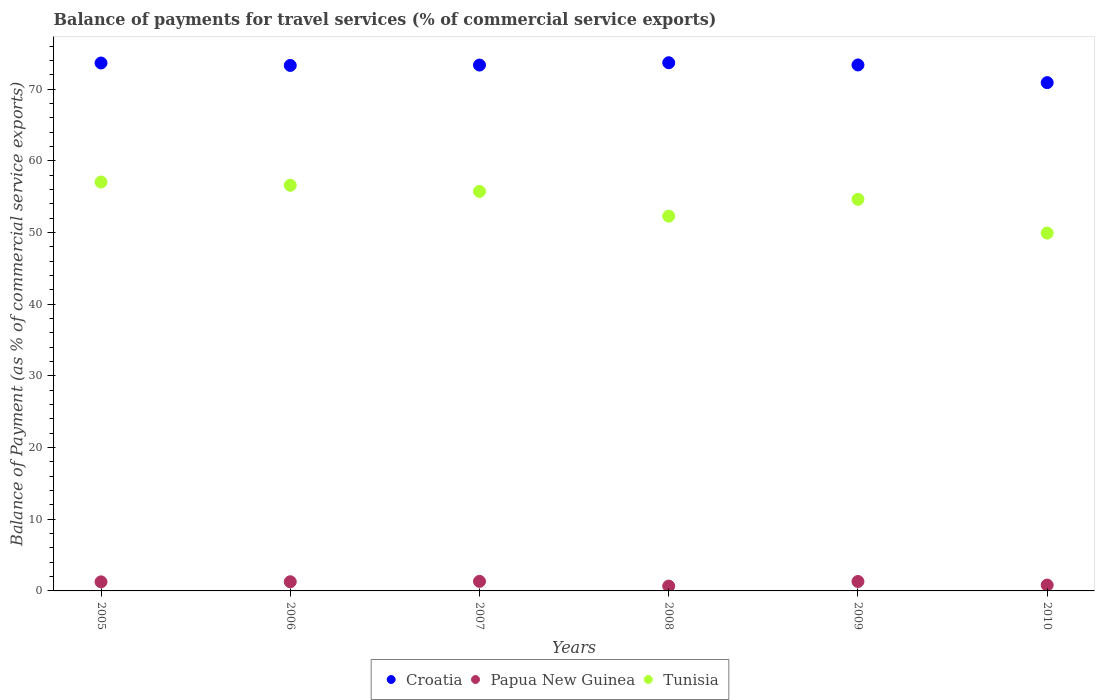What is the balance of payments for travel services in Tunisia in 2006?
Your response must be concise. 56.59. Across all years, what is the maximum balance of payments for travel services in Tunisia?
Your response must be concise. 57.04. Across all years, what is the minimum balance of payments for travel services in Croatia?
Offer a terse response. 70.91. What is the total balance of payments for travel services in Tunisia in the graph?
Offer a terse response. 326.22. What is the difference between the balance of payments for travel services in Papua New Guinea in 2005 and that in 2006?
Your answer should be very brief. -0.01. What is the difference between the balance of payments for travel services in Croatia in 2005 and the balance of payments for travel services in Papua New Guinea in 2008?
Ensure brevity in your answer.  72.97. What is the average balance of payments for travel services in Papua New Guinea per year?
Provide a succinct answer. 1.11. In the year 2008, what is the difference between the balance of payments for travel services in Croatia and balance of payments for travel services in Papua New Guinea?
Ensure brevity in your answer.  73.01. In how many years, is the balance of payments for travel services in Tunisia greater than 34 %?
Your answer should be very brief. 6. What is the ratio of the balance of payments for travel services in Papua New Guinea in 2007 to that in 2010?
Your answer should be very brief. 1.63. Is the difference between the balance of payments for travel services in Croatia in 2008 and 2010 greater than the difference between the balance of payments for travel services in Papua New Guinea in 2008 and 2010?
Give a very brief answer. Yes. What is the difference between the highest and the second highest balance of payments for travel services in Tunisia?
Keep it short and to the point. 0.45. What is the difference between the highest and the lowest balance of payments for travel services in Tunisia?
Give a very brief answer. 7.12. In how many years, is the balance of payments for travel services in Tunisia greater than the average balance of payments for travel services in Tunisia taken over all years?
Make the answer very short. 4. Is the balance of payments for travel services in Papua New Guinea strictly less than the balance of payments for travel services in Tunisia over the years?
Your answer should be very brief. Yes. How many dotlines are there?
Your response must be concise. 3. Does the graph contain grids?
Ensure brevity in your answer.  No. Where does the legend appear in the graph?
Offer a very short reply. Bottom center. How many legend labels are there?
Offer a terse response. 3. What is the title of the graph?
Keep it short and to the point. Balance of payments for travel services (% of commercial service exports). Does "Upper middle income" appear as one of the legend labels in the graph?
Your answer should be compact. No. What is the label or title of the X-axis?
Keep it short and to the point. Years. What is the label or title of the Y-axis?
Your response must be concise. Balance of Payment (as % of commercial service exports). What is the Balance of Payment (as % of commercial service exports) in Croatia in 2005?
Your answer should be compact. 73.65. What is the Balance of Payment (as % of commercial service exports) in Papua New Guinea in 2005?
Your answer should be very brief. 1.27. What is the Balance of Payment (as % of commercial service exports) in Tunisia in 2005?
Your answer should be compact. 57.04. What is the Balance of Payment (as % of commercial service exports) of Croatia in 2006?
Your answer should be compact. 73.31. What is the Balance of Payment (as % of commercial service exports) of Papua New Guinea in 2006?
Your answer should be very brief. 1.28. What is the Balance of Payment (as % of commercial service exports) in Tunisia in 2006?
Offer a very short reply. 56.59. What is the Balance of Payment (as % of commercial service exports) in Croatia in 2007?
Make the answer very short. 73.36. What is the Balance of Payment (as % of commercial service exports) of Papua New Guinea in 2007?
Keep it short and to the point. 1.33. What is the Balance of Payment (as % of commercial service exports) in Tunisia in 2007?
Offer a terse response. 55.74. What is the Balance of Payment (as % of commercial service exports) in Croatia in 2008?
Give a very brief answer. 73.69. What is the Balance of Payment (as % of commercial service exports) of Papua New Guinea in 2008?
Offer a very short reply. 0.68. What is the Balance of Payment (as % of commercial service exports) in Tunisia in 2008?
Provide a succinct answer. 52.29. What is the Balance of Payment (as % of commercial service exports) of Croatia in 2009?
Give a very brief answer. 73.38. What is the Balance of Payment (as % of commercial service exports) of Papua New Guinea in 2009?
Offer a very short reply. 1.31. What is the Balance of Payment (as % of commercial service exports) of Tunisia in 2009?
Provide a succinct answer. 54.63. What is the Balance of Payment (as % of commercial service exports) in Croatia in 2010?
Offer a terse response. 70.91. What is the Balance of Payment (as % of commercial service exports) of Papua New Guinea in 2010?
Ensure brevity in your answer.  0.82. What is the Balance of Payment (as % of commercial service exports) in Tunisia in 2010?
Offer a very short reply. 49.93. Across all years, what is the maximum Balance of Payment (as % of commercial service exports) in Croatia?
Your answer should be compact. 73.69. Across all years, what is the maximum Balance of Payment (as % of commercial service exports) in Papua New Guinea?
Offer a terse response. 1.33. Across all years, what is the maximum Balance of Payment (as % of commercial service exports) of Tunisia?
Provide a short and direct response. 57.04. Across all years, what is the minimum Balance of Payment (as % of commercial service exports) of Croatia?
Ensure brevity in your answer.  70.91. Across all years, what is the minimum Balance of Payment (as % of commercial service exports) in Papua New Guinea?
Ensure brevity in your answer.  0.68. Across all years, what is the minimum Balance of Payment (as % of commercial service exports) in Tunisia?
Ensure brevity in your answer.  49.93. What is the total Balance of Payment (as % of commercial service exports) of Croatia in the graph?
Provide a short and direct response. 438.3. What is the total Balance of Payment (as % of commercial service exports) of Papua New Guinea in the graph?
Offer a very short reply. 6.69. What is the total Balance of Payment (as % of commercial service exports) of Tunisia in the graph?
Ensure brevity in your answer.  326.22. What is the difference between the Balance of Payment (as % of commercial service exports) of Croatia in 2005 and that in 2006?
Your response must be concise. 0.34. What is the difference between the Balance of Payment (as % of commercial service exports) in Papua New Guinea in 2005 and that in 2006?
Offer a very short reply. -0.01. What is the difference between the Balance of Payment (as % of commercial service exports) of Tunisia in 2005 and that in 2006?
Your response must be concise. 0.45. What is the difference between the Balance of Payment (as % of commercial service exports) of Croatia in 2005 and that in 2007?
Ensure brevity in your answer.  0.29. What is the difference between the Balance of Payment (as % of commercial service exports) in Papua New Guinea in 2005 and that in 2007?
Provide a succinct answer. -0.07. What is the difference between the Balance of Payment (as % of commercial service exports) of Tunisia in 2005 and that in 2007?
Ensure brevity in your answer.  1.3. What is the difference between the Balance of Payment (as % of commercial service exports) in Croatia in 2005 and that in 2008?
Ensure brevity in your answer.  -0.04. What is the difference between the Balance of Payment (as % of commercial service exports) in Papua New Guinea in 2005 and that in 2008?
Your response must be concise. 0.59. What is the difference between the Balance of Payment (as % of commercial service exports) in Tunisia in 2005 and that in 2008?
Make the answer very short. 4.76. What is the difference between the Balance of Payment (as % of commercial service exports) in Croatia in 2005 and that in 2009?
Offer a terse response. 0.27. What is the difference between the Balance of Payment (as % of commercial service exports) of Papua New Guinea in 2005 and that in 2009?
Offer a very short reply. -0.05. What is the difference between the Balance of Payment (as % of commercial service exports) in Tunisia in 2005 and that in 2009?
Ensure brevity in your answer.  2.41. What is the difference between the Balance of Payment (as % of commercial service exports) of Croatia in 2005 and that in 2010?
Your answer should be very brief. 2.74. What is the difference between the Balance of Payment (as % of commercial service exports) of Papua New Guinea in 2005 and that in 2010?
Your answer should be compact. 0.45. What is the difference between the Balance of Payment (as % of commercial service exports) of Tunisia in 2005 and that in 2010?
Your response must be concise. 7.12. What is the difference between the Balance of Payment (as % of commercial service exports) in Croatia in 2006 and that in 2007?
Provide a short and direct response. -0.05. What is the difference between the Balance of Payment (as % of commercial service exports) of Papua New Guinea in 2006 and that in 2007?
Make the answer very short. -0.06. What is the difference between the Balance of Payment (as % of commercial service exports) of Tunisia in 2006 and that in 2007?
Your response must be concise. 0.85. What is the difference between the Balance of Payment (as % of commercial service exports) in Croatia in 2006 and that in 2008?
Ensure brevity in your answer.  -0.38. What is the difference between the Balance of Payment (as % of commercial service exports) in Papua New Guinea in 2006 and that in 2008?
Offer a terse response. 0.6. What is the difference between the Balance of Payment (as % of commercial service exports) in Tunisia in 2006 and that in 2008?
Your response must be concise. 4.31. What is the difference between the Balance of Payment (as % of commercial service exports) in Croatia in 2006 and that in 2009?
Make the answer very short. -0.07. What is the difference between the Balance of Payment (as % of commercial service exports) of Papua New Guinea in 2006 and that in 2009?
Ensure brevity in your answer.  -0.04. What is the difference between the Balance of Payment (as % of commercial service exports) in Tunisia in 2006 and that in 2009?
Provide a short and direct response. 1.96. What is the difference between the Balance of Payment (as % of commercial service exports) of Croatia in 2006 and that in 2010?
Provide a short and direct response. 2.4. What is the difference between the Balance of Payment (as % of commercial service exports) in Papua New Guinea in 2006 and that in 2010?
Provide a short and direct response. 0.46. What is the difference between the Balance of Payment (as % of commercial service exports) in Tunisia in 2006 and that in 2010?
Give a very brief answer. 6.67. What is the difference between the Balance of Payment (as % of commercial service exports) of Croatia in 2007 and that in 2008?
Provide a short and direct response. -0.32. What is the difference between the Balance of Payment (as % of commercial service exports) of Papua New Guinea in 2007 and that in 2008?
Offer a terse response. 0.66. What is the difference between the Balance of Payment (as % of commercial service exports) of Tunisia in 2007 and that in 2008?
Ensure brevity in your answer.  3.45. What is the difference between the Balance of Payment (as % of commercial service exports) in Croatia in 2007 and that in 2009?
Offer a very short reply. -0.02. What is the difference between the Balance of Payment (as % of commercial service exports) in Papua New Guinea in 2007 and that in 2009?
Provide a short and direct response. 0.02. What is the difference between the Balance of Payment (as % of commercial service exports) in Tunisia in 2007 and that in 2009?
Your response must be concise. 1.1. What is the difference between the Balance of Payment (as % of commercial service exports) in Croatia in 2007 and that in 2010?
Provide a succinct answer. 2.45. What is the difference between the Balance of Payment (as % of commercial service exports) in Papua New Guinea in 2007 and that in 2010?
Make the answer very short. 0.52. What is the difference between the Balance of Payment (as % of commercial service exports) of Tunisia in 2007 and that in 2010?
Keep it short and to the point. 5.81. What is the difference between the Balance of Payment (as % of commercial service exports) of Croatia in 2008 and that in 2009?
Keep it short and to the point. 0.31. What is the difference between the Balance of Payment (as % of commercial service exports) of Papua New Guinea in 2008 and that in 2009?
Your response must be concise. -0.64. What is the difference between the Balance of Payment (as % of commercial service exports) of Tunisia in 2008 and that in 2009?
Ensure brevity in your answer.  -2.35. What is the difference between the Balance of Payment (as % of commercial service exports) in Croatia in 2008 and that in 2010?
Provide a succinct answer. 2.78. What is the difference between the Balance of Payment (as % of commercial service exports) in Papua New Guinea in 2008 and that in 2010?
Your answer should be very brief. -0.14. What is the difference between the Balance of Payment (as % of commercial service exports) in Tunisia in 2008 and that in 2010?
Your answer should be very brief. 2.36. What is the difference between the Balance of Payment (as % of commercial service exports) of Croatia in 2009 and that in 2010?
Your answer should be very brief. 2.47. What is the difference between the Balance of Payment (as % of commercial service exports) in Papua New Guinea in 2009 and that in 2010?
Your response must be concise. 0.5. What is the difference between the Balance of Payment (as % of commercial service exports) of Tunisia in 2009 and that in 2010?
Provide a succinct answer. 4.71. What is the difference between the Balance of Payment (as % of commercial service exports) of Croatia in 2005 and the Balance of Payment (as % of commercial service exports) of Papua New Guinea in 2006?
Provide a short and direct response. 72.37. What is the difference between the Balance of Payment (as % of commercial service exports) in Croatia in 2005 and the Balance of Payment (as % of commercial service exports) in Tunisia in 2006?
Your answer should be compact. 17.06. What is the difference between the Balance of Payment (as % of commercial service exports) of Papua New Guinea in 2005 and the Balance of Payment (as % of commercial service exports) of Tunisia in 2006?
Provide a short and direct response. -55.33. What is the difference between the Balance of Payment (as % of commercial service exports) of Croatia in 2005 and the Balance of Payment (as % of commercial service exports) of Papua New Guinea in 2007?
Your response must be concise. 72.32. What is the difference between the Balance of Payment (as % of commercial service exports) of Croatia in 2005 and the Balance of Payment (as % of commercial service exports) of Tunisia in 2007?
Provide a succinct answer. 17.91. What is the difference between the Balance of Payment (as % of commercial service exports) of Papua New Guinea in 2005 and the Balance of Payment (as % of commercial service exports) of Tunisia in 2007?
Offer a very short reply. -54.47. What is the difference between the Balance of Payment (as % of commercial service exports) of Croatia in 2005 and the Balance of Payment (as % of commercial service exports) of Papua New Guinea in 2008?
Your answer should be very brief. 72.97. What is the difference between the Balance of Payment (as % of commercial service exports) in Croatia in 2005 and the Balance of Payment (as % of commercial service exports) in Tunisia in 2008?
Offer a very short reply. 21.36. What is the difference between the Balance of Payment (as % of commercial service exports) of Papua New Guinea in 2005 and the Balance of Payment (as % of commercial service exports) of Tunisia in 2008?
Provide a succinct answer. -51.02. What is the difference between the Balance of Payment (as % of commercial service exports) of Croatia in 2005 and the Balance of Payment (as % of commercial service exports) of Papua New Guinea in 2009?
Provide a short and direct response. 72.34. What is the difference between the Balance of Payment (as % of commercial service exports) of Croatia in 2005 and the Balance of Payment (as % of commercial service exports) of Tunisia in 2009?
Your answer should be very brief. 19.02. What is the difference between the Balance of Payment (as % of commercial service exports) in Papua New Guinea in 2005 and the Balance of Payment (as % of commercial service exports) in Tunisia in 2009?
Ensure brevity in your answer.  -53.37. What is the difference between the Balance of Payment (as % of commercial service exports) in Croatia in 2005 and the Balance of Payment (as % of commercial service exports) in Papua New Guinea in 2010?
Offer a terse response. 72.83. What is the difference between the Balance of Payment (as % of commercial service exports) in Croatia in 2005 and the Balance of Payment (as % of commercial service exports) in Tunisia in 2010?
Keep it short and to the point. 23.72. What is the difference between the Balance of Payment (as % of commercial service exports) of Papua New Guinea in 2005 and the Balance of Payment (as % of commercial service exports) of Tunisia in 2010?
Keep it short and to the point. -48.66. What is the difference between the Balance of Payment (as % of commercial service exports) of Croatia in 2006 and the Balance of Payment (as % of commercial service exports) of Papua New Guinea in 2007?
Keep it short and to the point. 71.97. What is the difference between the Balance of Payment (as % of commercial service exports) of Croatia in 2006 and the Balance of Payment (as % of commercial service exports) of Tunisia in 2007?
Offer a terse response. 17.57. What is the difference between the Balance of Payment (as % of commercial service exports) in Papua New Guinea in 2006 and the Balance of Payment (as % of commercial service exports) in Tunisia in 2007?
Offer a very short reply. -54.46. What is the difference between the Balance of Payment (as % of commercial service exports) in Croatia in 2006 and the Balance of Payment (as % of commercial service exports) in Papua New Guinea in 2008?
Provide a short and direct response. 72.63. What is the difference between the Balance of Payment (as % of commercial service exports) in Croatia in 2006 and the Balance of Payment (as % of commercial service exports) in Tunisia in 2008?
Your answer should be compact. 21.02. What is the difference between the Balance of Payment (as % of commercial service exports) in Papua New Guinea in 2006 and the Balance of Payment (as % of commercial service exports) in Tunisia in 2008?
Ensure brevity in your answer.  -51.01. What is the difference between the Balance of Payment (as % of commercial service exports) in Croatia in 2006 and the Balance of Payment (as % of commercial service exports) in Papua New Guinea in 2009?
Your answer should be compact. 71.99. What is the difference between the Balance of Payment (as % of commercial service exports) of Croatia in 2006 and the Balance of Payment (as % of commercial service exports) of Tunisia in 2009?
Offer a very short reply. 18.67. What is the difference between the Balance of Payment (as % of commercial service exports) in Papua New Guinea in 2006 and the Balance of Payment (as % of commercial service exports) in Tunisia in 2009?
Your response must be concise. -53.36. What is the difference between the Balance of Payment (as % of commercial service exports) of Croatia in 2006 and the Balance of Payment (as % of commercial service exports) of Papua New Guinea in 2010?
Your answer should be compact. 72.49. What is the difference between the Balance of Payment (as % of commercial service exports) in Croatia in 2006 and the Balance of Payment (as % of commercial service exports) in Tunisia in 2010?
Ensure brevity in your answer.  23.38. What is the difference between the Balance of Payment (as % of commercial service exports) in Papua New Guinea in 2006 and the Balance of Payment (as % of commercial service exports) in Tunisia in 2010?
Your answer should be compact. -48.65. What is the difference between the Balance of Payment (as % of commercial service exports) of Croatia in 2007 and the Balance of Payment (as % of commercial service exports) of Papua New Guinea in 2008?
Offer a very short reply. 72.69. What is the difference between the Balance of Payment (as % of commercial service exports) of Croatia in 2007 and the Balance of Payment (as % of commercial service exports) of Tunisia in 2008?
Provide a short and direct response. 21.08. What is the difference between the Balance of Payment (as % of commercial service exports) in Papua New Guinea in 2007 and the Balance of Payment (as % of commercial service exports) in Tunisia in 2008?
Your answer should be very brief. -50.95. What is the difference between the Balance of Payment (as % of commercial service exports) in Croatia in 2007 and the Balance of Payment (as % of commercial service exports) in Papua New Guinea in 2009?
Keep it short and to the point. 72.05. What is the difference between the Balance of Payment (as % of commercial service exports) of Croatia in 2007 and the Balance of Payment (as % of commercial service exports) of Tunisia in 2009?
Offer a terse response. 18.73. What is the difference between the Balance of Payment (as % of commercial service exports) in Papua New Guinea in 2007 and the Balance of Payment (as % of commercial service exports) in Tunisia in 2009?
Provide a succinct answer. -53.3. What is the difference between the Balance of Payment (as % of commercial service exports) in Croatia in 2007 and the Balance of Payment (as % of commercial service exports) in Papua New Guinea in 2010?
Keep it short and to the point. 72.55. What is the difference between the Balance of Payment (as % of commercial service exports) in Croatia in 2007 and the Balance of Payment (as % of commercial service exports) in Tunisia in 2010?
Your answer should be very brief. 23.44. What is the difference between the Balance of Payment (as % of commercial service exports) in Papua New Guinea in 2007 and the Balance of Payment (as % of commercial service exports) in Tunisia in 2010?
Provide a succinct answer. -48.59. What is the difference between the Balance of Payment (as % of commercial service exports) of Croatia in 2008 and the Balance of Payment (as % of commercial service exports) of Papua New Guinea in 2009?
Provide a short and direct response. 72.37. What is the difference between the Balance of Payment (as % of commercial service exports) in Croatia in 2008 and the Balance of Payment (as % of commercial service exports) in Tunisia in 2009?
Make the answer very short. 19.05. What is the difference between the Balance of Payment (as % of commercial service exports) of Papua New Guinea in 2008 and the Balance of Payment (as % of commercial service exports) of Tunisia in 2009?
Your answer should be very brief. -53.96. What is the difference between the Balance of Payment (as % of commercial service exports) in Croatia in 2008 and the Balance of Payment (as % of commercial service exports) in Papua New Guinea in 2010?
Provide a succinct answer. 72.87. What is the difference between the Balance of Payment (as % of commercial service exports) of Croatia in 2008 and the Balance of Payment (as % of commercial service exports) of Tunisia in 2010?
Your answer should be very brief. 23.76. What is the difference between the Balance of Payment (as % of commercial service exports) in Papua New Guinea in 2008 and the Balance of Payment (as % of commercial service exports) in Tunisia in 2010?
Give a very brief answer. -49.25. What is the difference between the Balance of Payment (as % of commercial service exports) of Croatia in 2009 and the Balance of Payment (as % of commercial service exports) of Papua New Guinea in 2010?
Give a very brief answer. 72.56. What is the difference between the Balance of Payment (as % of commercial service exports) in Croatia in 2009 and the Balance of Payment (as % of commercial service exports) in Tunisia in 2010?
Your response must be concise. 23.45. What is the difference between the Balance of Payment (as % of commercial service exports) of Papua New Guinea in 2009 and the Balance of Payment (as % of commercial service exports) of Tunisia in 2010?
Make the answer very short. -48.61. What is the average Balance of Payment (as % of commercial service exports) of Croatia per year?
Offer a very short reply. 73.05. What is the average Balance of Payment (as % of commercial service exports) in Papua New Guinea per year?
Your response must be concise. 1.11. What is the average Balance of Payment (as % of commercial service exports) of Tunisia per year?
Your response must be concise. 54.37. In the year 2005, what is the difference between the Balance of Payment (as % of commercial service exports) in Croatia and Balance of Payment (as % of commercial service exports) in Papua New Guinea?
Your response must be concise. 72.39. In the year 2005, what is the difference between the Balance of Payment (as % of commercial service exports) of Croatia and Balance of Payment (as % of commercial service exports) of Tunisia?
Give a very brief answer. 16.61. In the year 2005, what is the difference between the Balance of Payment (as % of commercial service exports) in Papua New Guinea and Balance of Payment (as % of commercial service exports) in Tunisia?
Give a very brief answer. -55.78. In the year 2006, what is the difference between the Balance of Payment (as % of commercial service exports) in Croatia and Balance of Payment (as % of commercial service exports) in Papua New Guinea?
Your answer should be compact. 72.03. In the year 2006, what is the difference between the Balance of Payment (as % of commercial service exports) of Croatia and Balance of Payment (as % of commercial service exports) of Tunisia?
Provide a short and direct response. 16.72. In the year 2006, what is the difference between the Balance of Payment (as % of commercial service exports) of Papua New Guinea and Balance of Payment (as % of commercial service exports) of Tunisia?
Keep it short and to the point. -55.31. In the year 2007, what is the difference between the Balance of Payment (as % of commercial service exports) of Croatia and Balance of Payment (as % of commercial service exports) of Papua New Guinea?
Ensure brevity in your answer.  72.03. In the year 2007, what is the difference between the Balance of Payment (as % of commercial service exports) of Croatia and Balance of Payment (as % of commercial service exports) of Tunisia?
Provide a short and direct response. 17.62. In the year 2007, what is the difference between the Balance of Payment (as % of commercial service exports) in Papua New Guinea and Balance of Payment (as % of commercial service exports) in Tunisia?
Your answer should be very brief. -54.4. In the year 2008, what is the difference between the Balance of Payment (as % of commercial service exports) of Croatia and Balance of Payment (as % of commercial service exports) of Papua New Guinea?
Keep it short and to the point. 73.01. In the year 2008, what is the difference between the Balance of Payment (as % of commercial service exports) in Croatia and Balance of Payment (as % of commercial service exports) in Tunisia?
Offer a terse response. 21.4. In the year 2008, what is the difference between the Balance of Payment (as % of commercial service exports) in Papua New Guinea and Balance of Payment (as % of commercial service exports) in Tunisia?
Provide a short and direct response. -51.61. In the year 2009, what is the difference between the Balance of Payment (as % of commercial service exports) of Croatia and Balance of Payment (as % of commercial service exports) of Papua New Guinea?
Your answer should be compact. 72.06. In the year 2009, what is the difference between the Balance of Payment (as % of commercial service exports) of Croatia and Balance of Payment (as % of commercial service exports) of Tunisia?
Give a very brief answer. 18.74. In the year 2009, what is the difference between the Balance of Payment (as % of commercial service exports) in Papua New Guinea and Balance of Payment (as % of commercial service exports) in Tunisia?
Provide a succinct answer. -53.32. In the year 2010, what is the difference between the Balance of Payment (as % of commercial service exports) in Croatia and Balance of Payment (as % of commercial service exports) in Papua New Guinea?
Offer a terse response. 70.09. In the year 2010, what is the difference between the Balance of Payment (as % of commercial service exports) in Croatia and Balance of Payment (as % of commercial service exports) in Tunisia?
Provide a short and direct response. 20.98. In the year 2010, what is the difference between the Balance of Payment (as % of commercial service exports) of Papua New Guinea and Balance of Payment (as % of commercial service exports) of Tunisia?
Your answer should be compact. -49.11. What is the ratio of the Balance of Payment (as % of commercial service exports) in Croatia in 2005 to that in 2006?
Your answer should be compact. 1. What is the ratio of the Balance of Payment (as % of commercial service exports) in Papua New Guinea in 2005 to that in 2006?
Make the answer very short. 0.99. What is the ratio of the Balance of Payment (as % of commercial service exports) of Papua New Guinea in 2005 to that in 2007?
Your answer should be compact. 0.95. What is the ratio of the Balance of Payment (as % of commercial service exports) in Tunisia in 2005 to that in 2007?
Make the answer very short. 1.02. What is the ratio of the Balance of Payment (as % of commercial service exports) of Papua New Guinea in 2005 to that in 2008?
Keep it short and to the point. 1.87. What is the ratio of the Balance of Payment (as % of commercial service exports) in Tunisia in 2005 to that in 2008?
Your answer should be compact. 1.09. What is the ratio of the Balance of Payment (as % of commercial service exports) in Croatia in 2005 to that in 2009?
Your response must be concise. 1. What is the ratio of the Balance of Payment (as % of commercial service exports) of Papua New Guinea in 2005 to that in 2009?
Give a very brief answer. 0.96. What is the ratio of the Balance of Payment (as % of commercial service exports) in Tunisia in 2005 to that in 2009?
Provide a short and direct response. 1.04. What is the ratio of the Balance of Payment (as % of commercial service exports) of Croatia in 2005 to that in 2010?
Give a very brief answer. 1.04. What is the ratio of the Balance of Payment (as % of commercial service exports) of Papua New Guinea in 2005 to that in 2010?
Your answer should be compact. 1.55. What is the ratio of the Balance of Payment (as % of commercial service exports) in Tunisia in 2005 to that in 2010?
Keep it short and to the point. 1.14. What is the ratio of the Balance of Payment (as % of commercial service exports) of Papua New Guinea in 2006 to that in 2007?
Keep it short and to the point. 0.96. What is the ratio of the Balance of Payment (as % of commercial service exports) of Tunisia in 2006 to that in 2007?
Your response must be concise. 1.02. What is the ratio of the Balance of Payment (as % of commercial service exports) in Papua New Guinea in 2006 to that in 2008?
Provide a succinct answer. 1.89. What is the ratio of the Balance of Payment (as % of commercial service exports) in Tunisia in 2006 to that in 2008?
Provide a short and direct response. 1.08. What is the ratio of the Balance of Payment (as % of commercial service exports) in Croatia in 2006 to that in 2009?
Provide a short and direct response. 1. What is the ratio of the Balance of Payment (as % of commercial service exports) of Papua New Guinea in 2006 to that in 2009?
Offer a very short reply. 0.97. What is the ratio of the Balance of Payment (as % of commercial service exports) in Tunisia in 2006 to that in 2009?
Offer a terse response. 1.04. What is the ratio of the Balance of Payment (as % of commercial service exports) in Croatia in 2006 to that in 2010?
Ensure brevity in your answer.  1.03. What is the ratio of the Balance of Payment (as % of commercial service exports) of Papua New Guinea in 2006 to that in 2010?
Provide a short and direct response. 1.56. What is the ratio of the Balance of Payment (as % of commercial service exports) of Tunisia in 2006 to that in 2010?
Your response must be concise. 1.13. What is the ratio of the Balance of Payment (as % of commercial service exports) in Croatia in 2007 to that in 2008?
Your answer should be compact. 1. What is the ratio of the Balance of Payment (as % of commercial service exports) of Papua New Guinea in 2007 to that in 2008?
Give a very brief answer. 1.97. What is the ratio of the Balance of Payment (as % of commercial service exports) of Tunisia in 2007 to that in 2008?
Offer a terse response. 1.07. What is the ratio of the Balance of Payment (as % of commercial service exports) of Papua New Guinea in 2007 to that in 2009?
Give a very brief answer. 1.01. What is the ratio of the Balance of Payment (as % of commercial service exports) of Tunisia in 2007 to that in 2009?
Provide a short and direct response. 1.02. What is the ratio of the Balance of Payment (as % of commercial service exports) of Croatia in 2007 to that in 2010?
Make the answer very short. 1.03. What is the ratio of the Balance of Payment (as % of commercial service exports) of Papua New Guinea in 2007 to that in 2010?
Offer a very short reply. 1.63. What is the ratio of the Balance of Payment (as % of commercial service exports) of Tunisia in 2007 to that in 2010?
Provide a succinct answer. 1.12. What is the ratio of the Balance of Payment (as % of commercial service exports) in Croatia in 2008 to that in 2009?
Offer a terse response. 1. What is the ratio of the Balance of Payment (as % of commercial service exports) of Papua New Guinea in 2008 to that in 2009?
Make the answer very short. 0.51. What is the ratio of the Balance of Payment (as % of commercial service exports) of Tunisia in 2008 to that in 2009?
Your answer should be compact. 0.96. What is the ratio of the Balance of Payment (as % of commercial service exports) in Croatia in 2008 to that in 2010?
Offer a very short reply. 1.04. What is the ratio of the Balance of Payment (as % of commercial service exports) of Papua New Guinea in 2008 to that in 2010?
Keep it short and to the point. 0.83. What is the ratio of the Balance of Payment (as % of commercial service exports) of Tunisia in 2008 to that in 2010?
Provide a short and direct response. 1.05. What is the ratio of the Balance of Payment (as % of commercial service exports) in Croatia in 2009 to that in 2010?
Provide a short and direct response. 1.03. What is the ratio of the Balance of Payment (as % of commercial service exports) in Papua New Guinea in 2009 to that in 2010?
Ensure brevity in your answer.  1.61. What is the ratio of the Balance of Payment (as % of commercial service exports) of Tunisia in 2009 to that in 2010?
Offer a terse response. 1.09. What is the difference between the highest and the second highest Balance of Payment (as % of commercial service exports) of Croatia?
Keep it short and to the point. 0.04. What is the difference between the highest and the second highest Balance of Payment (as % of commercial service exports) of Papua New Guinea?
Keep it short and to the point. 0.02. What is the difference between the highest and the second highest Balance of Payment (as % of commercial service exports) in Tunisia?
Your answer should be very brief. 0.45. What is the difference between the highest and the lowest Balance of Payment (as % of commercial service exports) of Croatia?
Give a very brief answer. 2.78. What is the difference between the highest and the lowest Balance of Payment (as % of commercial service exports) in Papua New Guinea?
Give a very brief answer. 0.66. What is the difference between the highest and the lowest Balance of Payment (as % of commercial service exports) in Tunisia?
Ensure brevity in your answer.  7.12. 